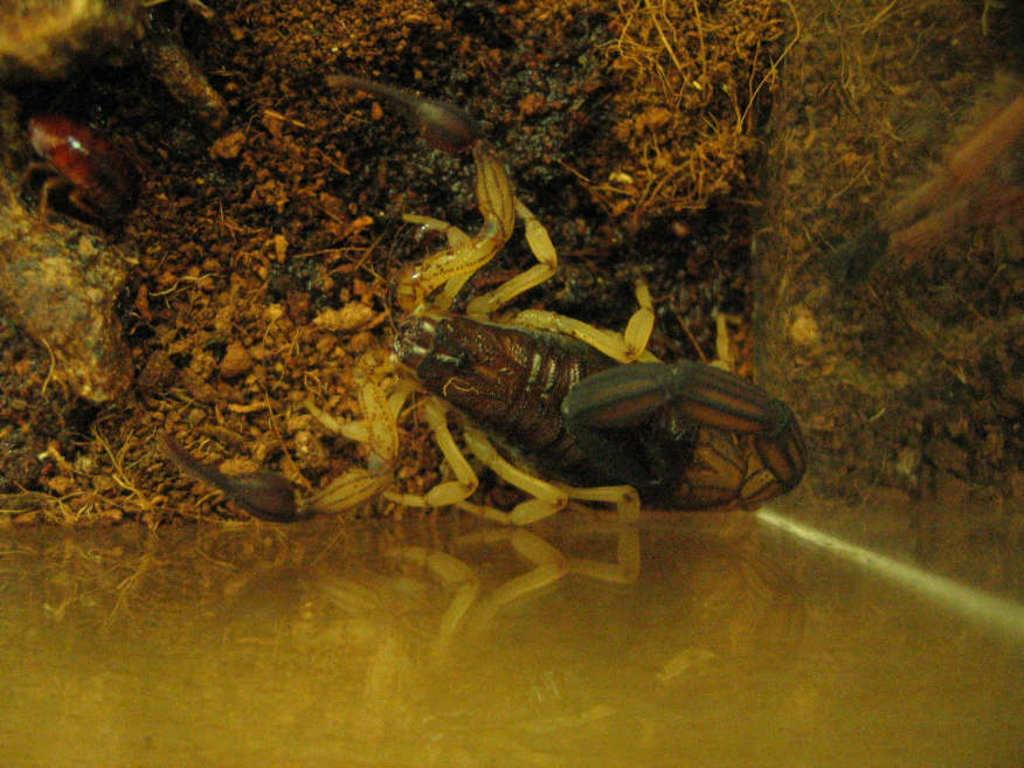What type of creature can be seen in the image? There is an insect in the image. What colors are present on the insect? The insect is in brown and black colors. Where is the insect located in the image? The insect is in the soil. Can you describe the quality of the image's bottom? The bottom of the image is blurred. What type of mint is being used to calm the insect's nerves in the image? There is no mint or reference to nerves in the image; it features an insect in the soil. 